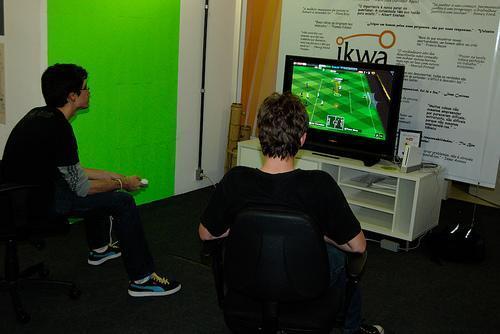How many TVs are in this picture?
Give a very brief answer. 1. 